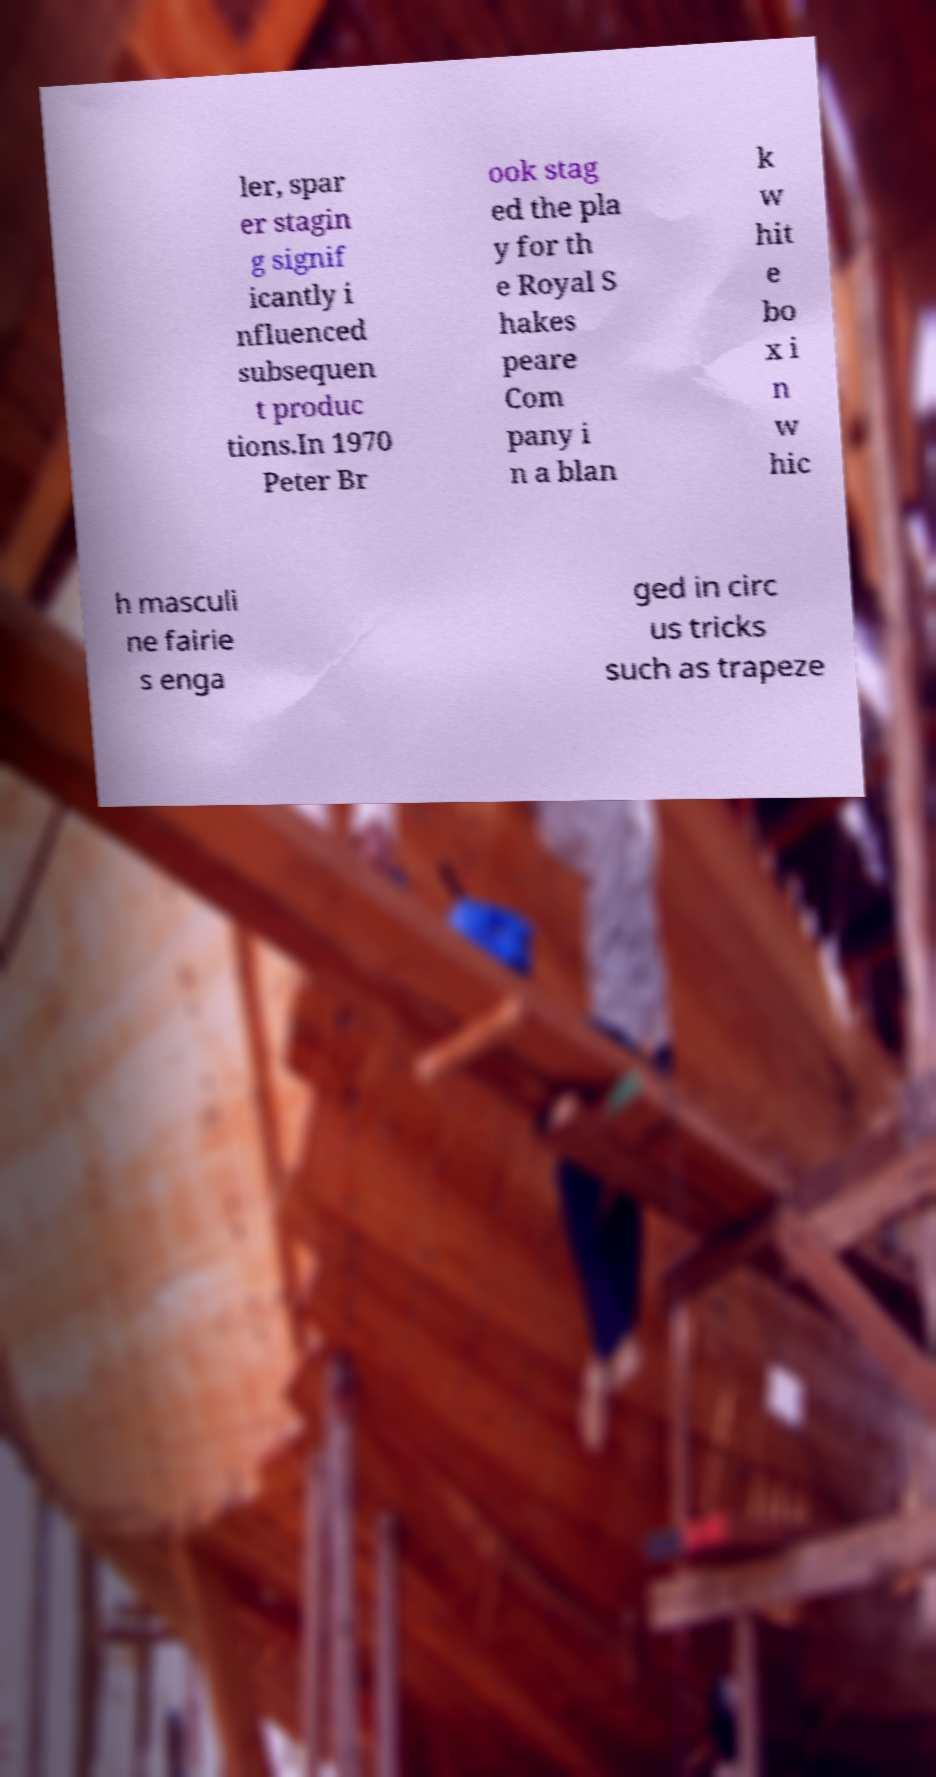Could you assist in decoding the text presented in this image and type it out clearly? ler, spar er stagin g signif icantly i nfluenced subsequen t produc tions.In 1970 Peter Br ook stag ed the pla y for th e Royal S hakes peare Com pany i n a blan k w hit e bo x i n w hic h masculi ne fairie s enga ged in circ us tricks such as trapeze 